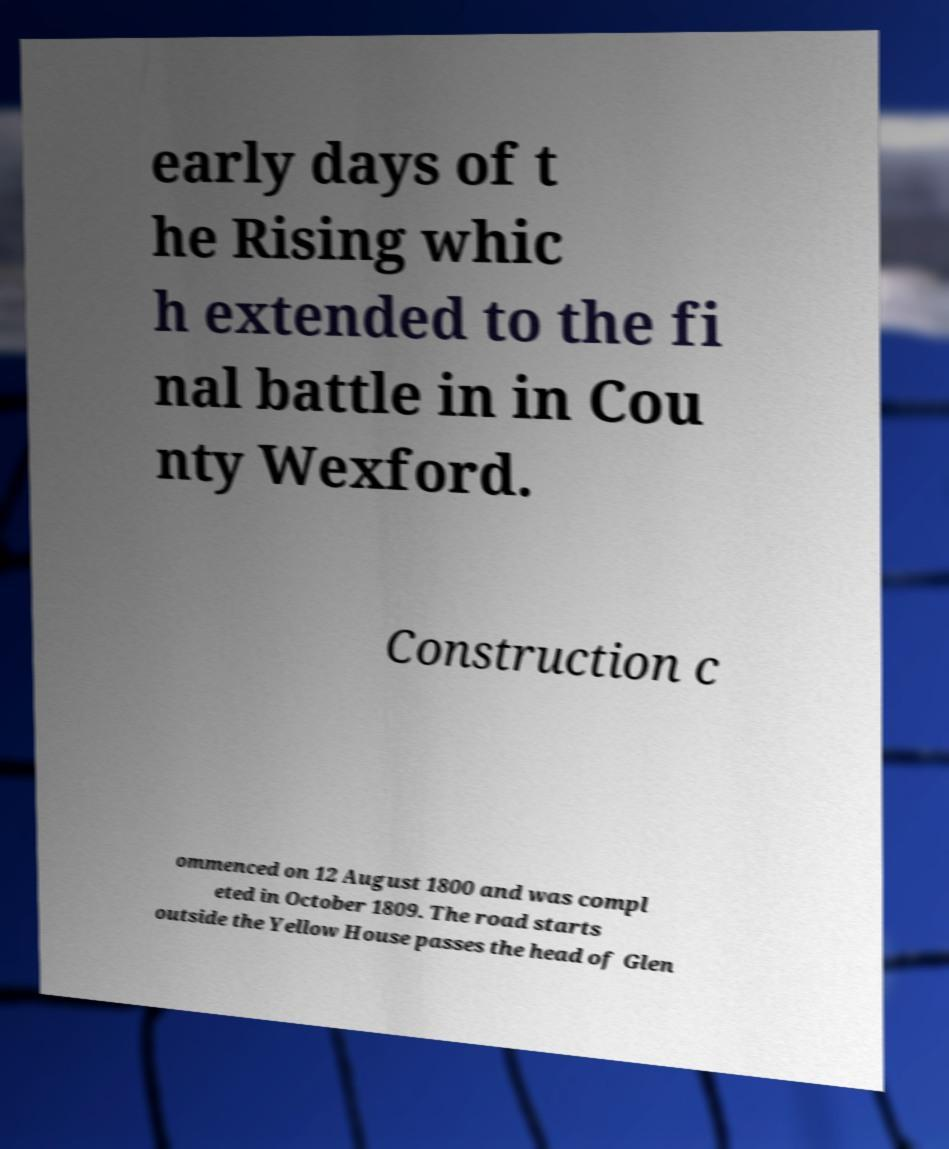Could you extract and type out the text from this image? early days of t he Rising whic h extended to the fi nal battle in in Cou nty Wexford. Construction c ommenced on 12 August 1800 and was compl eted in October 1809. The road starts outside the Yellow House passes the head of Glen 